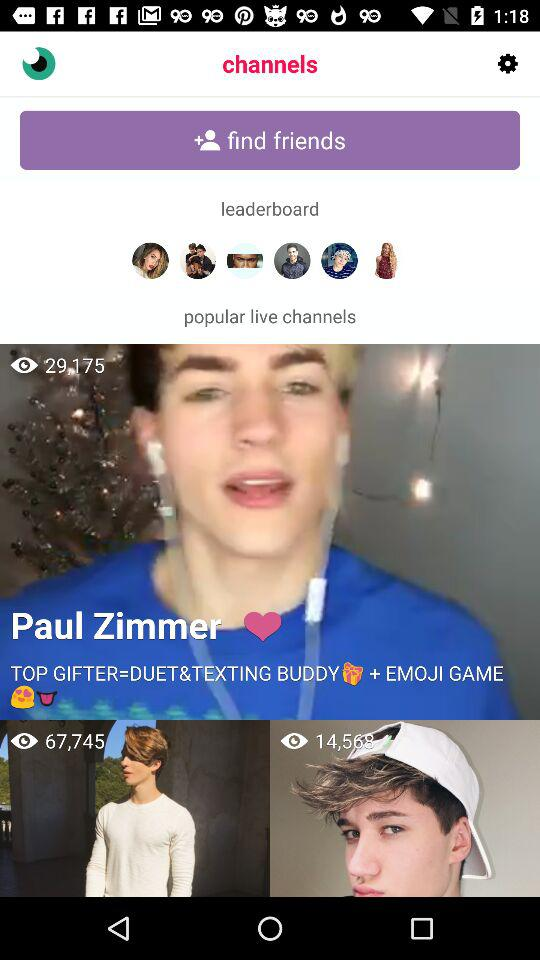What is the profile name? The profile name is Paul Zimmer. 